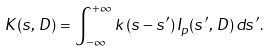<formula> <loc_0><loc_0><loc_500><loc_500>K ( s , \, D ) = \int _ { - \infty } ^ { + \infty } \, k ( s - s ^ { \prime } ) \, I _ { p } ( s ^ { \prime } , \, D ) \, d s ^ { \prime } .</formula> 